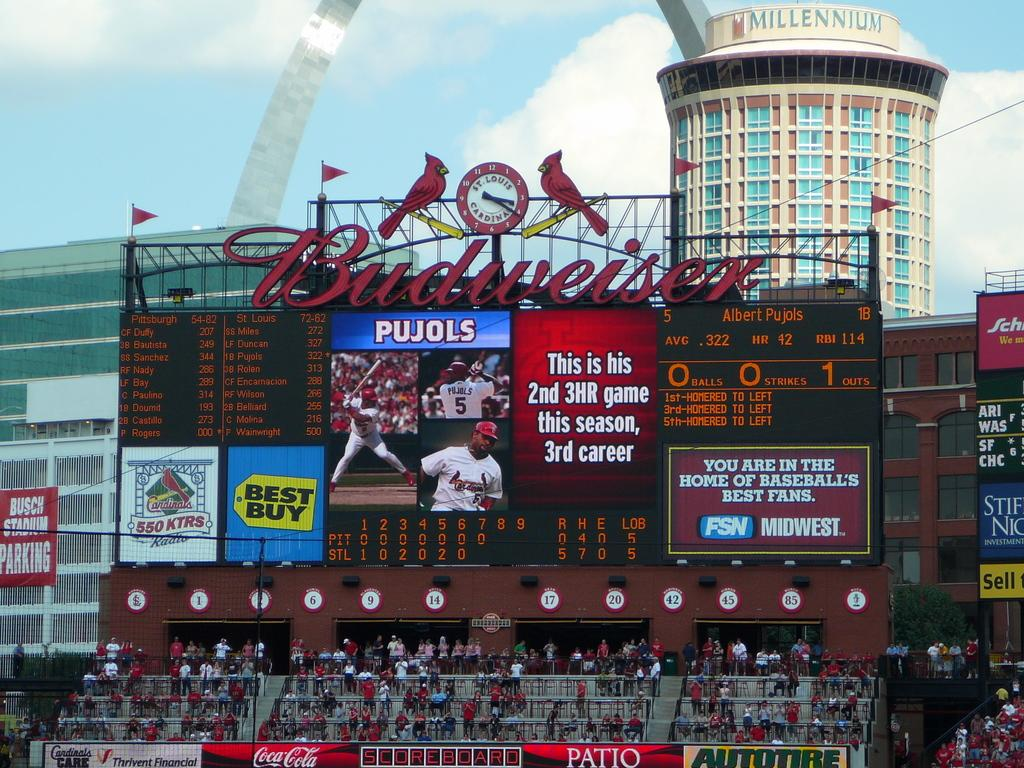Provide a one-sentence caption for the provided image. Albert Pujols has hit three home runs in this baseball game. 